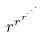Convert formula to latex. <formula><loc_0><loc_0><loc_500><loc_500>r ^ { r ^ { r ^ { \cdot ^ { \cdot ^ { \cdot } } } } }</formula> 